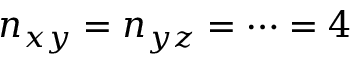Convert formula to latex. <formula><loc_0><loc_0><loc_500><loc_500>n _ { x y } = n _ { y z } = \cdots = 4</formula> 